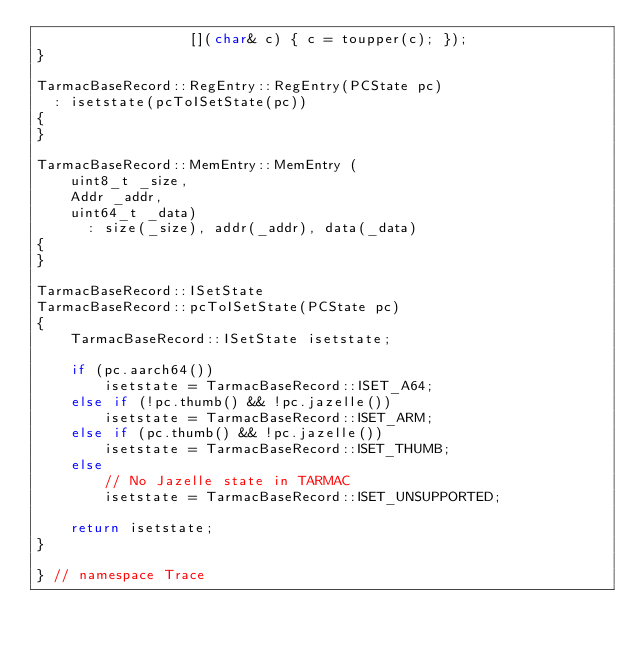Convert code to text. <code><loc_0><loc_0><loc_500><loc_500><_C++_>                  [](char& c) { c = toupper(c); });
}

TarmacBaseRecord::RegEntry::RegEntry(PCState pc)
  : isetstate(pcToISetState(pc))
{
}

TarmacBaseRecord::MemEntry::MemEntry (
    uint8_t _size,
    Addr _addr,
    uint64_t _data)
      : size(_size), addr(_addr), data(_data)
{
}

TarmacBaseRecord::ISetState
TarmacBaseRecord::pcToISetState(PCState pc)
{
    TarmacBaseRecord::ISetState isetstate;

    if (pc.aarch64())
        isetstate = TarmacBaseRecord::ISET_A64;
    else if (!pc.thumb() && !pc.jazelle())
        isetstate = TarmacBaseRecord::ISET_ARM;
    else if (pc.thumb() && !pc.jazelle())
        isetstate = TarmacBaseRecord::ISET_THUMB;
    else
        // No Jazelle state in TARMAC
        isetstate = TarmacBaseRecord::ISET_UNSUPPORTED;

    return isetstate;
}

} // namespace Trace
</code> 